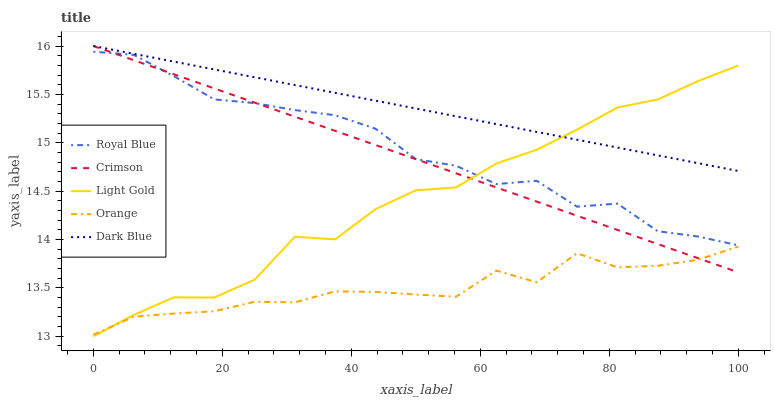Does Orange have the minimum area under the curve?
Answer yes or no. Yes. Does Dark Blue have the maximum area under the curve?
Answer yes or no. Yes. Does Royal Blue have the minimum area under the curve?
Answer yes or no. No. Does Royal Blue have the maximum area under the curve?
Answer yes or no. No. Is Crimson the smoothest?
Answer yes or no. Yes. Is Royal Blue the roughest?
Answer yes or no. Yes. Is Orange the smoothest?
Answer yes or no. No. Is Orange the roughest?
Answer yes or no. No. Does Light Gold have the lowest value?
Answer yes or no. Yes. Does Royal Blue have the lowest value?
Answer yes or no. No. Does Dark Blue have the highest value?
Answer yes or no. Yes. Does Royal Blue have the highest value?
Answer yes or no. No. Is Royal Blue less than Dark Blue?
Answer yes or no. Yes. Is Dark Blue greater than Royal Blue?
Answer yes or no. Yes. Does Light Gold intersect Orange?
Answer yes or no. Yes. Is Light Gold less than Orange?
Answer yes or no. No. Is Light Gold greater than Orange?
Answer yes or no. No. Does Royal Blue intersect Dark Blue?
Answer yes or no. No. 